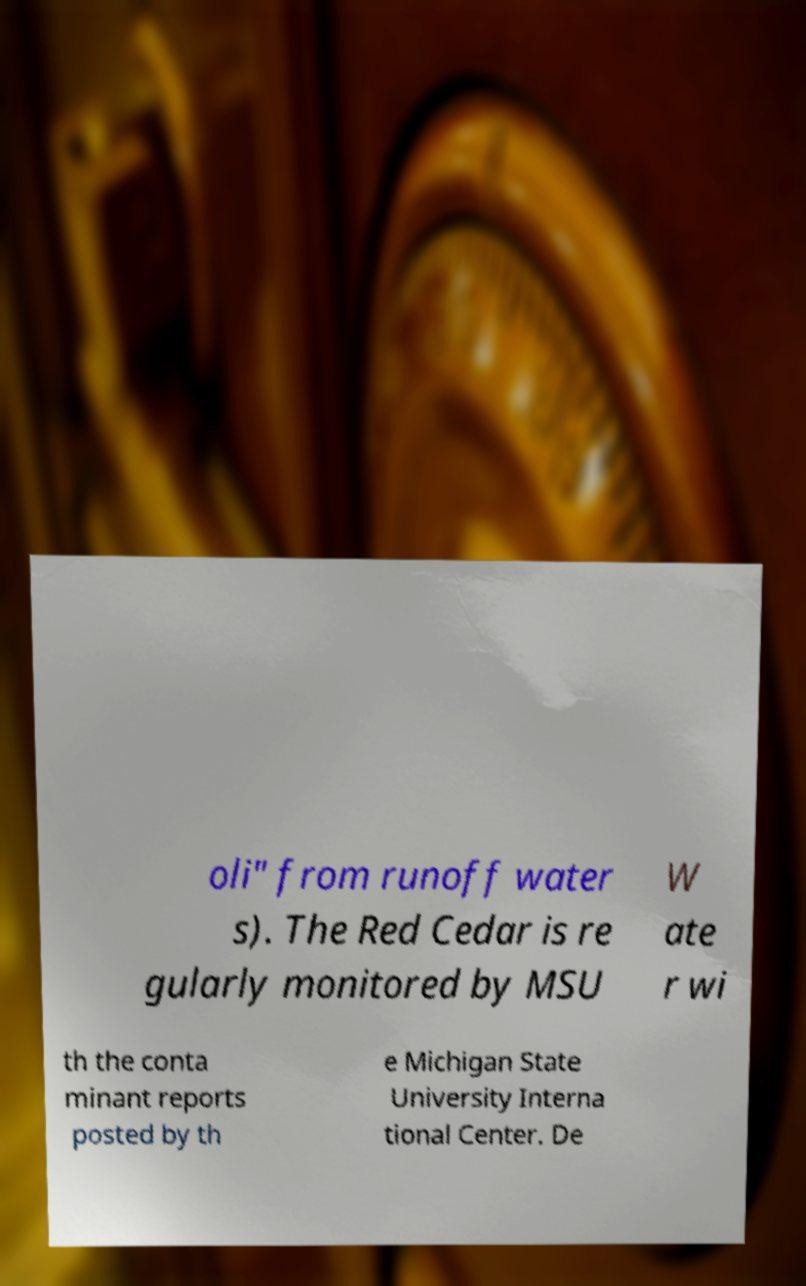Please read and relay the text visible in this image. What does it say? oli" from runoff water s). The Red Cedar is re gularly monitored by MSU W ate r wi th the conta minant reports posted by th e Michigan State University Interna tional Center. De 